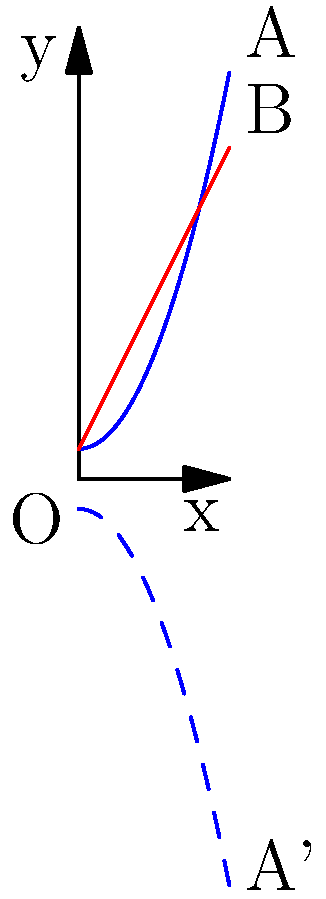The graph shows the outcomes of automated financial planning (blue curve) versus manual financial planning (red line) over time. The blue dashed curve represents the reflection of the automated planning curve across a line. What is the equation of the line of reflection? To find the line of reflection, we need to follow these steps:

1) The original automated planning curve (blue) is given by the function $f(x) = 0.5x^2 + 1$.

2) The reflected curve (blue dashed) appears to be a reflection across a horizontal line.

3) For a horizontal line of reflection with equation $y = k$, the reflection of a point $(x, y)$ would be $(x, 2k - y)$.

4) We can see that the y-intercept of the original curve (point O) is at (0, 1), and its reflection (on the dashed curve) appears to be at (0, 1).

5) This means that the line of reflection passes through the midpoint of these two points, which is (0, 1).

6) Therefore, the equation of the line of reflection is $y = 1$.

7) We can verify this by checking another point. For example, point A at (5, 13.5) is reflected to A' at approximately (5, -11.5). The midpoint of these is indeed on the line $y = 1$.
Answer: $y = 1$ 